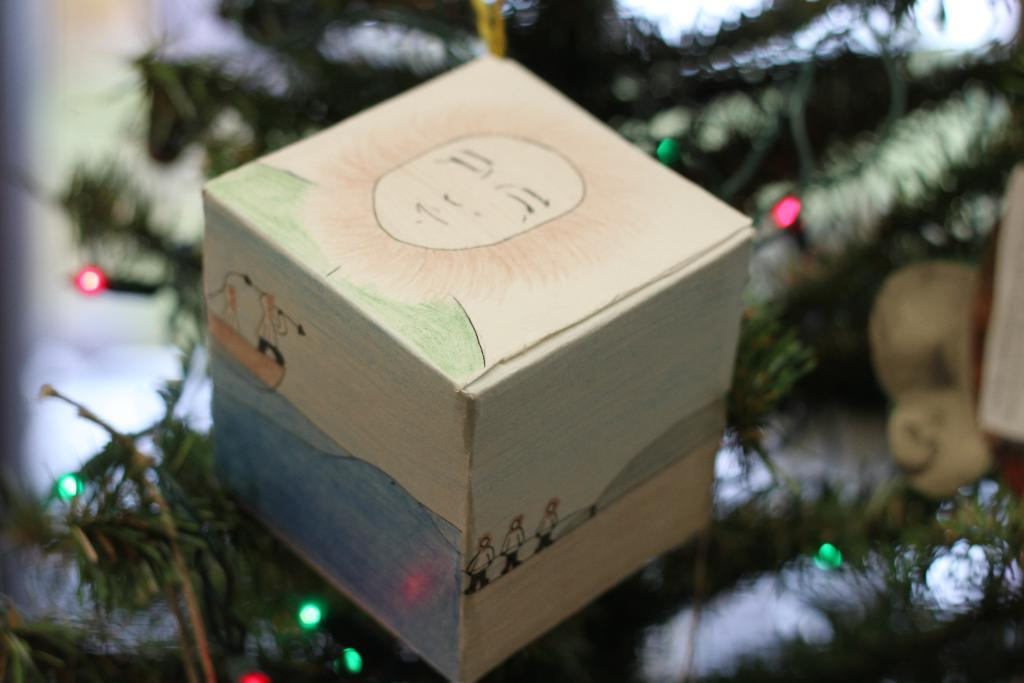What type of tree is present in the image? There is an xmas tree in the image. What other object can be seen in the image? There is a cardboard box in the image. What can be observed about the xmas tree in the image? There are lights visible in the image. What is the smell of the scene in the image? There is no information about the smell in the image, as it is a visual medium. 